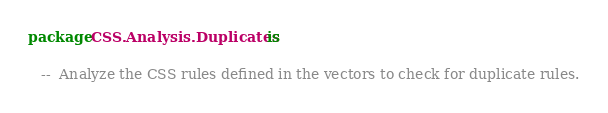Convert code to text. <code><loc_0><loc_0><loc_500><loc_500><_Ada_>package CSS.Analysis.Duplicates is

   --  Analyze the CSS rules defined in the vectors to check for duplicate rules.</code> 